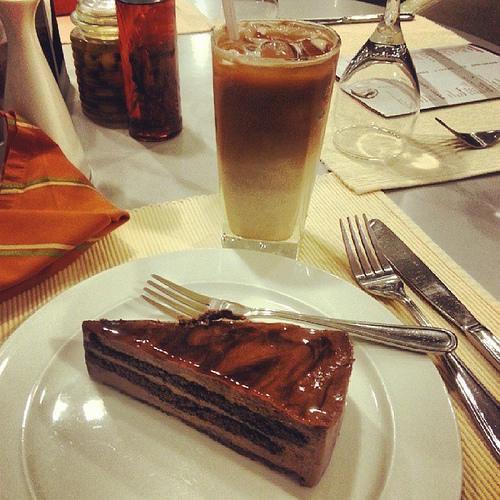How many glasses are on the table?
Give a very brief answer. 2. 